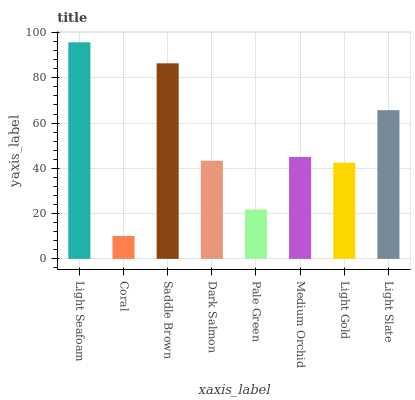Is Coral the minimum?
Answer yes or no. Yes. Is Light Seafoam the maximum?
Answer yes or no. Yes. Is Saddle Brown the minimum?
Answer yes or no. No. Is Saddle Brown the maximum?
Answer yes or no. No. Is Saddle Brown greater than Coral?
Answer yes or no. Yes. Is Coral less than Saddle Brown?
Answer yes or no. Yes. Is Coral greater than Saddle Brown?
Answer yes or no. No. Is Saddle Brown less than Coral?
Answer yes or no. No. Is Medium Orchid the high median?
Answer yes or no. Yes. Is Dark Salmon the low median?
Answer yes or no. Yes. Is Coral the high median?
Answer yes or no. No. Is Light Slate the low median?
Answer yes or no. No. 